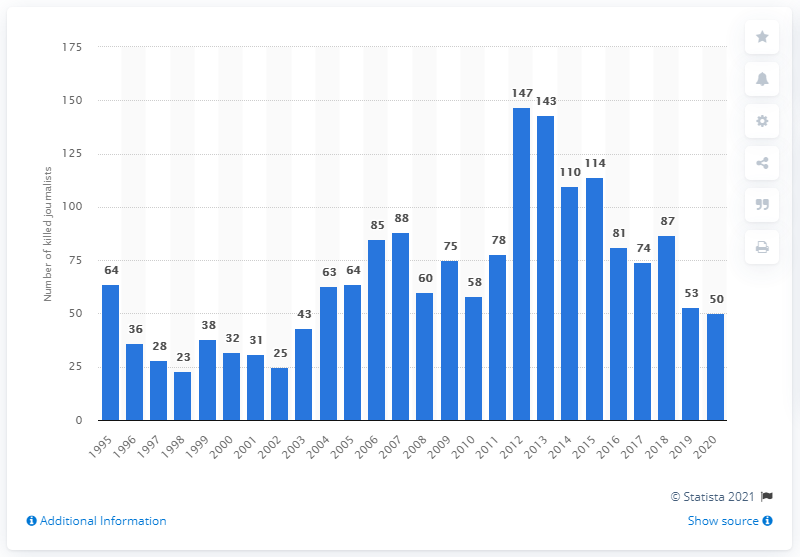Outline some significant characteristics in this image. In 2003, the number of journalists killed was the lowest in 2020. In 2020, a total of 50 journalists were killed worldwide. In the year 2012, 147 journalists were killed. 